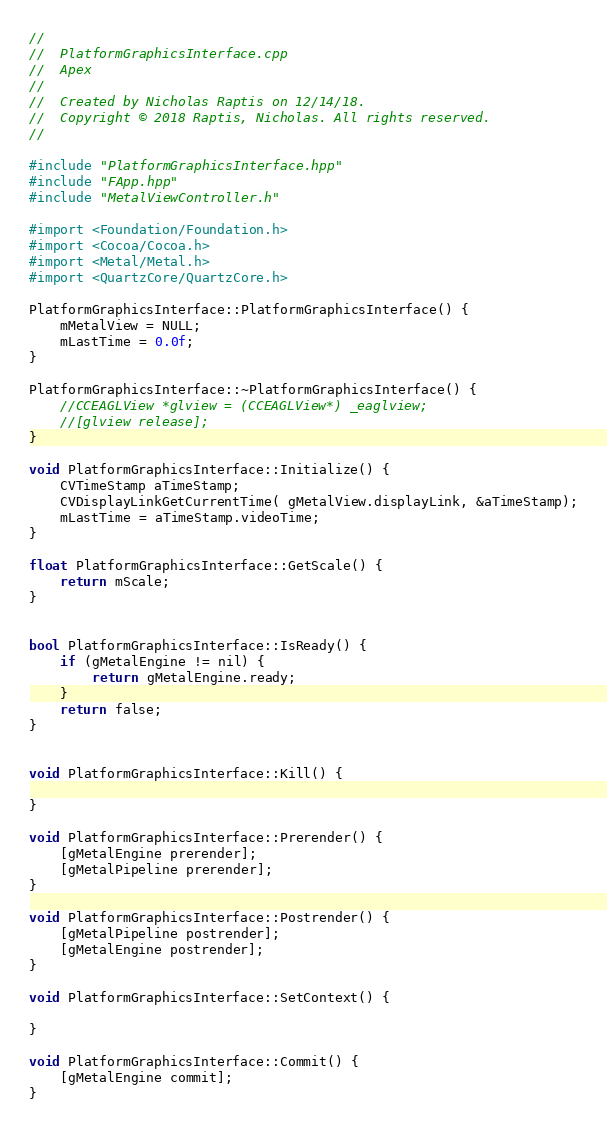Convert code to text. <code><loc_0><loc_0><loc_500><loc_500><_ObjectiveC_>//
//  PlatformGraphicsInterface.cpp
//  Apex
//
//  Created by Nicholas Raptis on 12/14/18.
//  Copyright © 2018 Raptis, Nicholas. All rights reserved.
//

#include "PlatformGraphicsInterface.hpp"
#include "FApp.hpp"
#include "MetalViewController.h"

#import <Foundation/Foundation.h>
#import <Cocoa/Cocoa.h>
#import <Metal/Metal.h>
#import <QuartzCore/QuartzCore.h>

PlatformGraphicsInterface::PlatformGraphicsInterface() {
    mMetalView = NULL;
    mLastTime = 0.0f;
}

PlatformGraphicsInterface::~PlatformGraphicsInterface() {
    //CCEAGLView *glview = (CCEAGLView*) _eaglview;
    //[glview release];
}

void PlatformGraphicsInterface::Initialize() {
    CVTimeStamp aTimeStamp;
    CVDisplayLinkGetCurrentTime( gMetalView.displayLink, &aTimeStamp);
    mLastTime = aTimeStamp.videoTime;
}

float PlatformGraphicsInterface::GetScale() {
    return mScale;
}


bool PlatformGraphicsInterface::IsReady() {
    if (gMetalEngine != nil) {
        return gMetalEngine.ready;
    }
    return false;
}


void PlatformGraphicsInterface::Kill() {
    
}

void PlatformGraphicsInterface::Prerender() {
    [gMetalEngine prerender];
    [gMetalPipeline prerender];
}

void PlatformGraphicsInterface::Postrender() {
    [gMetalPipeline postrender];
    [gMetalEngine postrender];
}

void PlatformGraphicsInterface::SetContext() {
    
}

void PlatformGraphicsInterface::Commit() {
    [gMetalEngine commit];
}

</code> 